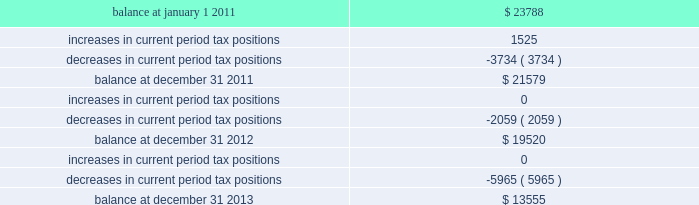The table summarizes the changes in the company 2019s valuation allowance: .
Included in 2013 is a discrete tax benefit totaling $ 2979 associated with an entity re-organization within the company 2019s market-based segment that allowed for the utilization of state net operating loss carryforwards and the release of an associated valuation allowance .
Note 14 : employee benefits pension and other postretirement benefits the company maintains noncontributory defined benefit pension plans covering eligible employees of its regulated utility and shared services operations .
Benefits under the plans are based on the employee 2019s years of service and compensation .
The pension plans have been closed for all employees .
The pension plans were closed for most employees hired on or after january 1 , 2006 .
Union employees hired on or after january 1 , 2001 had their accrued benefit frozen and will be able to receive this benefit as a lump sum upon termination or retirement .
Union employees hired on or after january 1 , 2001 and non-union employees hired on or after january 1 , 2006 are provided with a 5.25% ( 5.25 % ) of base pay defined contribution plan .
The company does not participate in a multiemployer plan .
The company 2019s pension funding practice is to contribute at least the greater of the minimum amount required by the employee retirement income security act of 1974 or the normal cost .
Further , the company will consider additional contributions if needed to avoid 201cat risk 201d status and benefit restrictions under the pension protection act of 2006 .
The company may also consider increased contributions , based on other financial requirements and the plans 2019 funded position .
Pension plan assets are invested in a number of actively managed and indexed investments including equity and bond mutual funds , fixed income securities , guaranteed interest contracts with insurance companies and real estate investment trusts ( 201creits 201d ) .
Pension expense in excess of the amount contributed to the pension plans is deferred by certain regulated subsidiaries pending future recovery in rates charged for utility services as contributions are made to the plans .
( see note 6 ) the company also has unfunded noncontributory supplemental non-qualified pension plans that provide additional retirement benefits to certain employees .
The company maintains other postretirement benefit plans providing varying levels of medical and life insurance to eligible retirees .
The retiree welfare plans are closed for union employees hired on or after january 1 , 2006 .
The plans had previously closed for non-union employees hired on or after january 1 , 2002 .
The company 2019s policy is to fund other postretirement benefit costs for rate-making purposes .
Assets of the plans are invested in equity mutual funds , bond mutual funds and fixed income securities. .
What is the percentage of the discrete ax benefit as a part of the balance at december 312013? 
Rationale: the percentage of a number is 2979 divide by the year end balance multiplied by 100
Computations: (2979 / 13555)
Answer: 0.21977. 